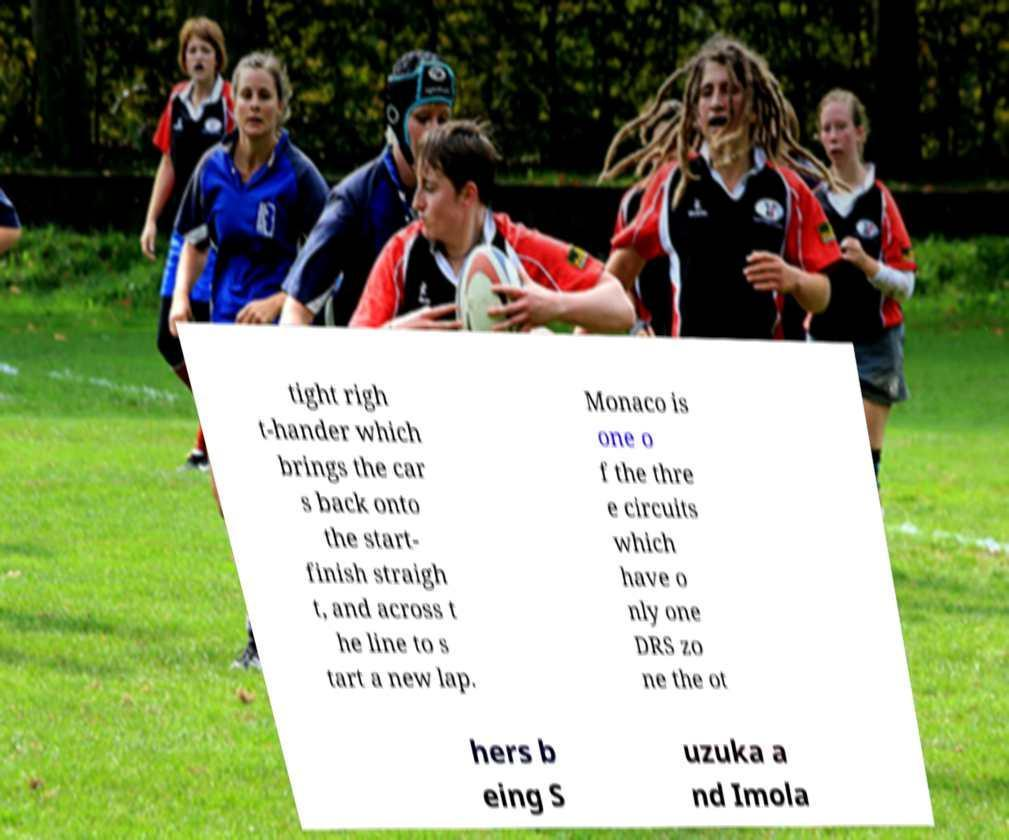Could you extract and type out the text from this image? tight righ t-hander which brings the car s back onto the start- finish straigh t, and across t he line to s tart a new lap. Monaco is one o f the thre e circuits which have o nly one DRS zo ne the ot hers b eing S uzuka a nd Imola 